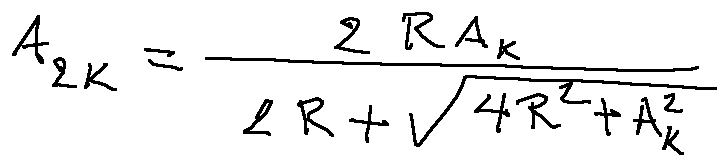<formula> <loc_0><loc_0><loc_500><loc_500>A _ { 2 k } = \frac { 2 R A _ { k } } { 2 R + \sqrt { 4 R ^ { 2 } + A _ { k } ^ { 2 } } }</formula> 